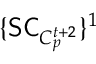Convert formula to latex. <formula><loc_0><loc_0><loc_500><loc_500>\{ S C _ { C _ { p } ^ { t + 2 } } \} ^ { 1 }</formula> 